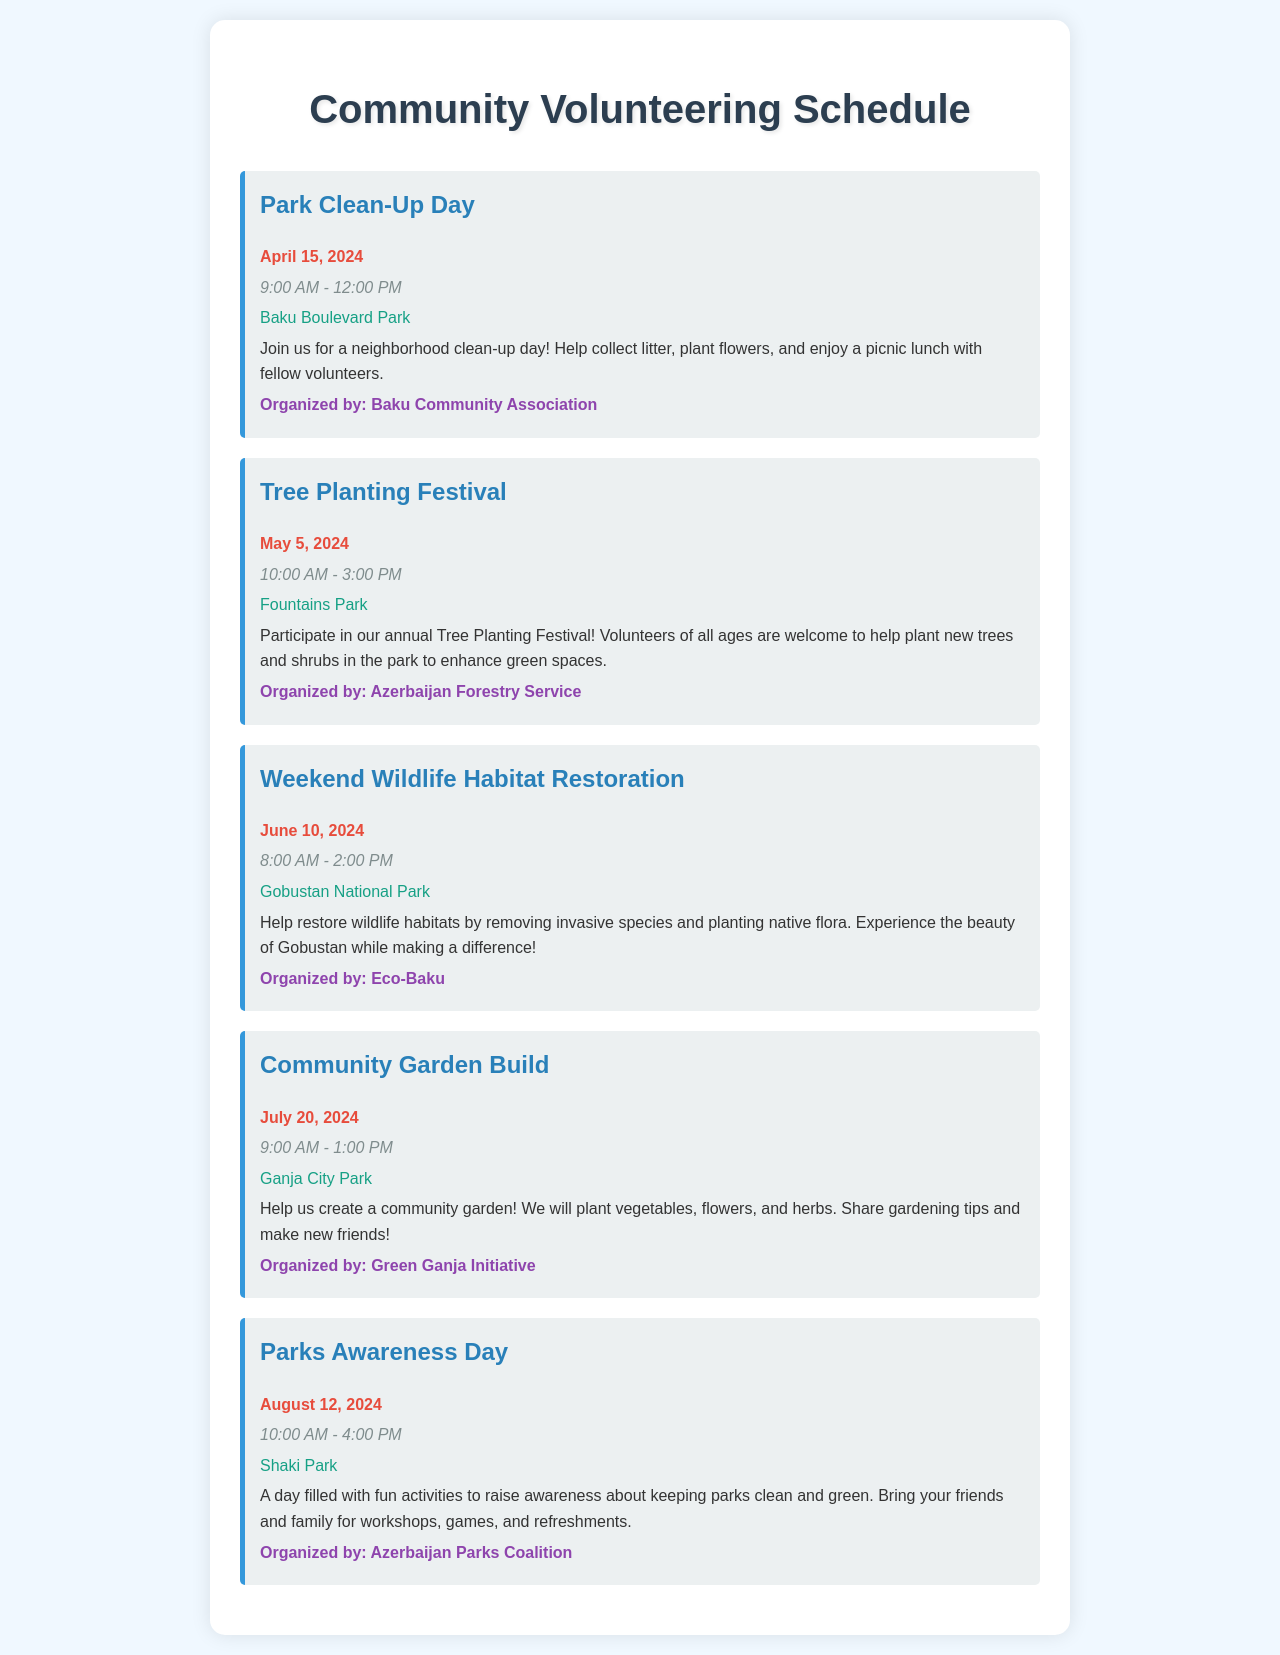What is the date of the Park Clean-Up Day? The Park Clean-Up Day is scheduled for April 15, 2024, as mentioned in the document.
Answer: April 15, 2024 What time does the Tree Planting Festival start? The Tree Planting Festival begins at 10:00 AM, as stated in the event details.
Answer: 10:00 AM Where is the Weekend Wildlife Habitat Restoration taking place? The event is located at Gobustan National Park, as noted in the location section.
Answer: Gobustan National Park Which organization is organizing the Community Garden Build? The Community Garden Build is organized by the Green Ganja Initiative, as specified in the document.
Answer: Green Ganja Initiative How long will the Parks Awareness Day last? Parks Awareness Day runs from 10:00 AM to 4:00 PM, which totals 6 hours.
Answer: 6 hours What type of activities will be at Parks Awareness Day? The event will include workshops, games, and refreshments to raise awareness about parks.
Answer: Workshops, games, and refreshments How many events are listed in the schedule? There are a total of five events mentioned in the document.
Answer: Five events What is the main purpose of the Tree Planting Festival? The main purpose is to enhance green spaces by planting trees and shrubs, as described in the text.
Answer: Enhance green spaces What is the goal of the Weekend Wildlife Habitat Restoration? The goal is to restore wildlife habitats by removing invasive species and planting native flora.
Answer: Restore wildlife habitats 